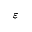Convert formula to latex. <formula><loc_0><loc_0><loc_500><loc_500>\varepsilon</formula> 